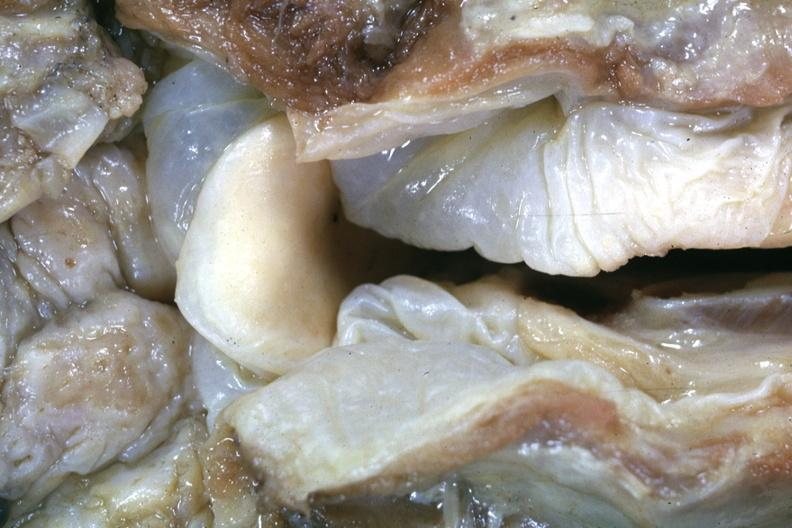what is a more distant view of this specimen after fixation?
Answer the question using a single word or phrase. Close-up very edematous hypopharyngeal mucosa with opened larynx very good example lesion seldom seen at autopsy slide 